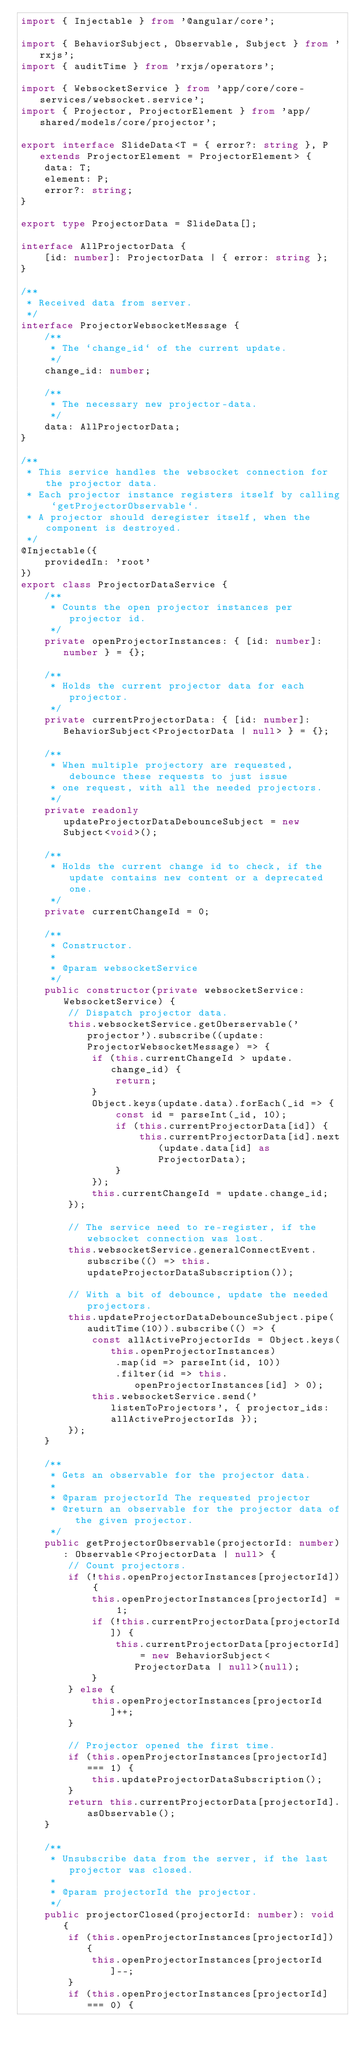Convert code to text. <code><loc_0><loc_0><loc_500><loc_500><_TypeScript_>import { Injectable } from '@angular/core';

import { BehaviorSubject, Observable, Subject } from 'rxjs';
import { auditTime } from 'rxjs/operators';

import { WebsocketService } from 'app/core/core-services/websocket.service';
import { Projector, ProjectorElement } from 'app/shared/models/core/projector';

export interface SlideData<T = { error?: string }, P extends ProjectorElement = ProjectorElement> {
    data: T;
    element: P;
    error?: string;
}

export type ProjectorData = SlideData[];

interface AllProjectorData {
    [id: number]: ProjectorData | { error: string };
}

/**
 * Received data from server.
 */
interface ProjectorWebsocketMessage {
    /**
     * The `change_id` of the current update.
     */
    change_id: number;

    /**
     * The necessary new projector-data.
     */
    data: AllProjectorData;
}

/**
 * This service handles the websocket connection for the projector data.
 * Each projector instance registers itself by calling `getProjectorObservable`.
 * A projector should deregister itself, when the component is destroyed.
 */
@Injectable({
    providedIn: 'root'
})
export class ProjectorDataService {
    /**
     * Counts the open projector instances per projector id.
     */
    private openProjectorInstances: { [id: number]: number } = {};

    /**
     * Holds the current projector data for each projector.
     */
    private currentProjectorData: { [id: number]: BehaviorSubject<ProjectorData | null> } = {};

    /**
     * When multiple projectory are requested, debounce these requests to just issue
     * one request, with all the needed projectors.
     */
    private readonly updateProjectorDataDebounceSubject = new Subject<void>();

    /**
     * Holds the current change id to check, if the update contains new content or a deprecated one.
     */
    private currentChangeId = 0;

    /**
     * Constructor.
     *
     * @param websocketService
     */
    public constructor(private websocketService: WebsocketService) {
        // Dispatch projector data.
        this.websocketService.getOberservable('projector').subscribe((update: ProjectorWebsocketMessage) => {
            if (this.currentChangeId > update.change_id) {
                return;
            }
            Object.keys(update.data).forEach(_id => {
                const id = parseInt(_id, 10);
                if (this.currentProjectorData[id]) {
                    this.currentProjectorData[id].next(update.data[id] as ProjectorData);
                }
            });
            this.currentChangeId = update.change_id;
        });

        // The service need to re-register, if the websocket connection was lost.
        this.websocketService.generalConnectEvent.subscribe(() => this.updateProjectorDataSubscription());

        // With a bit of debounce, update the needed projectors.
        this.updateProjectorDataDebounceSubject.pipe(auditTime(10)).subscribe(() => {
            const allActiveProjectorIds = Object.keys(this.openProjectorInstances)
                .map(id => parseInt(id, 10))
                .filter(id => this.openProjectorInstances[id] > 0);
            this.websocketService.send('listenToProjectors', { projector_ids: allActiveProjectorIds });
        });
    }

    /**
     * Gets an observable for the projector data.
     *
     * @param projectorId The requested projector
     * @return an observable for the projector data of the given projector.
     */
    public getProjectorObservable(projectorId: number): Observable<ProjectorData | null> {
        // Count projectors.
        if (!this.openProjectorInstances[projectorId]) {
            this.openProjectorInstances[projectorId] = 1;
            if (!this.currentProjectorData[projectorId]) {
                this.currentProjectorData[projectorId] = new BehaviorSubject<ProjectorData | null>(null);
            }
        } else {
            this.openProjectorInstances[projectorId]++;
        }

        // Projector opened the first time.
        if (this.openProjectorInstances[projectorId] === 1) {
            this.updateProjectorDataSubscription();
        }
        return this.currentProjectorData[projectorId].asObservable();
    }

    /**
     * Unsubscribe data from the server, if the last projector was closed.
     *
     * @param projectorId the projector.
     */
    public projectorClosed(projectorId: number): void {
        if (this.openProjectorInstances[projectorId]) {
            this.openProjectorInstances[projectorId]--;
        }
        if (this.openProjectorInstances[projectorId] === 0) {</code> 